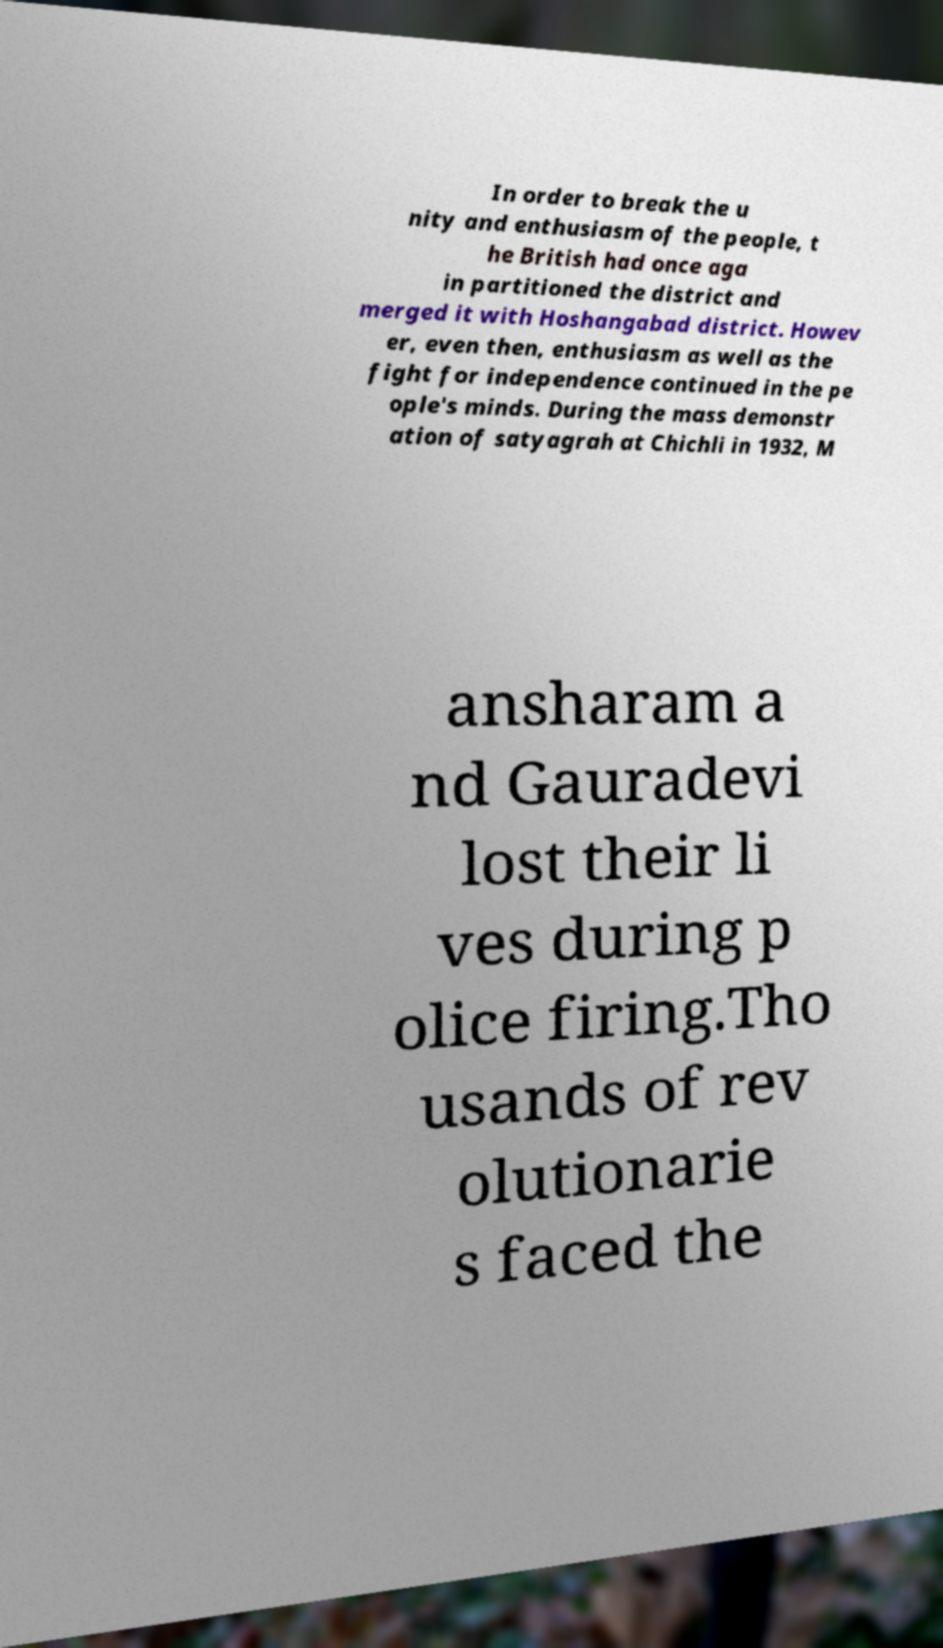Could you extract and type out the text from this image? In order to break the u nity and enthusiasm of the people, t he British had once aga in partitioned the district and merged it with Hoshangabad district. Howev er, even then, enthusiasm as well as the fight for independence continued in the pe ople's minds. During the mass demonstr ation of satyagrah at Chichli in 1932, M ansharam a nd Gauradevi lost their li ves during p olice firing.Tho usands of rev olutionarie s faced the 